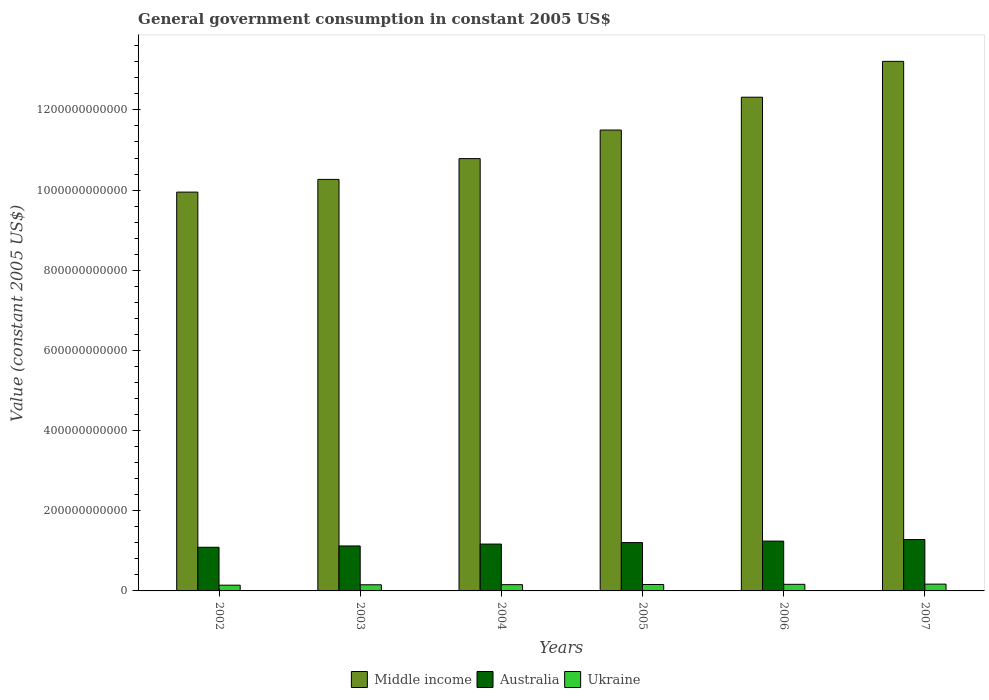How many different coloured bars are there?
Offer a very short reply. 3. How many groups of bars are there?
Offer a very short reply. 6. Are the number of bars on each tick of the X-axis equal?
Your response must be concise. Yes. How many bars are there on the 1st tick from the left?
Ensure brevity in your answer.  3. How many bars are there on the 3rd tick from the right?
Keep it short and to the point. 3. What is the label of the 6th group of bars from the left?
Offer a terse response. 2007. What is the government conusmption in Middle income in 2004?
Offer a very short reply. 1.08e+12. Across all years, what is the maximum government conusmption in Middle income?
Keep it short and to the point. 1.32e+12. Across all years, what is the minimum government conusmption in Ukraine?
Give a very brief answer. 1.43e+1. What is the total government conusmption in Ukraine in the graph?
Your response must be concise. 9.47e+1. What is the difference between the government conusmption in Australia in 2005 and that in 2006?
Provide a succinct answer. -3.73e+09. What is the difference between the government conusmption in Ukraine in 2006 and the government conusmption in Australia in 2004?
Provide a short and direct response. -1.00e+11. What is the average government conusmption in Middle income per year?
Give a very brief answer. 1.13e+12. In the year 2002, what is the difference between the government conusmption in Ukraine and government conusmption in Middle income?
Offer a very short reply. -9.81e+11. What is the ratio of the government conusmption in Ukraine in 2002 to that in 2006?
Give a very brief answer. 0.87. Is the difference between the government conusmption in Ukraine in 2004 and 2005 greater than the difference between the government conusmption in Middle income in 2004 and 2005?
Ensure brevity in your answer.  Yes. What is the difference between the highest and the second highest government conusmption in Australia?
Make the answer very short. 3.94e+09. What is the difference between the highest and the lowest government conusmption in Middle income?
Your response must be concise. 3.26e+11. In how many years, is the government conusmption in Middle income greater than the average government conusmption in Middle income taken over all years?
Make the answer very short. 3. Is the sum of the government conusmption in Australia in 2003 and 2005 greater than the maximum government conusmption in Ukraine across all years?
Provide a short and direct response. Yes. What does the 1st bar from the left in 2004 represents?
Your response must be concise. Middle income. What does the 1st bar from the right in 2003 represents?
Make the answer very short. Ukraine. What is the difference between two consecutive major ticks on the Y-axis?
Offer a terse response. 2.00e+11. Does the graph contain any zero values?
Your answer should be very brief. No. Where does the legend appear in the graph?
Make the answer very short. Bottom center. How are the legend labels stacked?
Offer a terse response. Horizontal. What is the title of the graph?
Make the answer very short. General government consumption in constant 2005 US$. What is the label or title of the X-axis?
Give a very brief answer. Years. What is the label or title of the Y-axis?
Offer a very short reply. Value (constant 2005 US$). What is the Value (constant 2005 US$) of Middle income in 2002?
Your response must be concise. 9.95e+11. What is the Value (constant 2005 US$) of Australia in 2002?
Ensure brevity in your answer.  1.09e+11. What is the Value (constant 2005 US$) in Ukraine in 2002?
Your answer should be very brief. 1.43e+1. What is the Value (constant 2005 US$) of Middle income in 2003?
Keep it short and to the point. 1.03e+12. What is the Value (constant 2005 US$) of Australia in 2003?
Offer a very short reply. 1.12e+11. What is the Value (constant 2005 US$) of Ukraine in 2003?
Your answer should be very brief. 1.53e+1. What is the Value (constant 2005 US$) in Middle income in 2004?
Your answer should be compact. 1.08e+12. What is the Value (constant 2005 US$) in Australia in 2004?
Offer a very short reply. 1.17e+11. What is the Value (constant 2005 US$) in Ukraine in 2004?
Your answer should be very brief. 1.56e+1. What is the Value (constant 2005 US$) in Middle income in 2005?
Your response must be concise. 1.15e+12. What is the Value (constant 2005 US$) of Australia in 2005?
Ensure brevity in your answer.  1.21e+11. What is the Value (constant 2005 US$) in Ukraine in 2005?
Your answer should be compact. 1.61e+1. What is the Value (constant 2005 US$) in Middle income in 2006?
Provide a succinct answer. 1.23e+12. What is the Value (constant 2005 US$) of Australia in 2006?
Give a very brief answer. 1.24e+11. What is the Value (constant 2005 US$) of Ukraine in 2006?
Provide a succinct answer. 1.65e+1. What is the Value (constant 2005 US$) of Middle income in 2007?
Keep it short and to the point. 1.32e+12. What is the Value (constant 2005 US$) in Australia in 2007?
Provide a succinct answer. 1.28e+11. What is the Value (constant 2005 US$) of Ukraine in 2007?
Make the answer very short. 1.69e+1. Across all years, what is the maximum Value (constant 2005 US$) in Middle income?
Provide a succinct answer. 1.32e+12. Across all years, what is the maximum Value (constant 2005 US$) in Australia?
Provide a short and direct response. 1.28e+11. Across all years, what is the maximum Value (constant 2005 US$) in Ukraine?
Your answer should be compact. 1.69e+1. Across all years, what is the minimum Value (constant 2005 US$) of Middle income?
Give a very brief answer. 9.95e+11. Across all years, what is the minimum Value (constant 2005 US$) in Australia?
Give a very brief answer. 1.09e+11. Across all years, what is the minimum Value (constant 2005 US$) in Ukraine?
Provide a succinct answer. 1.43e+1. What is the total Value (constant 2005 US$) in Middle income in the graph?
Keep it short and to the point. 6.80e+12. What is the total Value (constant 2005 US$) of Australia in the graph?
Offer a terse response. 7.11e+11. What is the total Value (constant 2005 US$) of Ukraine in the graph?
Give a very brief answer. 9.47e+1. What is the difference between the Value (constant 2005 US$) in Middle income in 2002 and that in 2003?
Give a very brief answer. -3.17e+1. What is the difference between the Value (constant 2005 US$) in Australia in 2002 and that in 2003?
Ensure brevity in your answer.  -3.25e+09. What is the difference between the Value (constant 2005 US$) in Ukraine in 2002 and that in 2003?
Your response must be concise. -9.89e+08. What is the difference between the Value (constant 2005 US$) of Middle income in 2002 and that in 2004?
Provide a succinct answer. -8.35e+1. What is the difference between the Value (constant 2005 US$) of Australia in 2002 and that in 2004?
Offer a very short reply. -7.94e+09. What is the difference between the Value (constant 2005 US$) in Ukraine in 2002 and that in 2004?
Provide a short and direct response. -1.26e+09. What is the difference between the Value (constant 2005 US$) in Middle income in 2002 and that in 2005?
Provide a short and direct response. -1.55e+11. What is the difference between the Value (constant 2005 US$) in Australia in 2002 and that in 2005?
Provide a succinct answer. -1.16e+1. What is the difference between the Value (constant 2005 US$) of Ukraine in 2002 and that in 2005?
Make the answer very short. -1.72e+09. What is the difference between the Value (constant 2005 US$) in Middle income in 2002 and that in 2006?
Provide a short and direct response. -2.37e+11. What is the difference between the Value (constant 2005 US$) of Australia in 2002 and that in 2006?
Ensure brevity in your answer.  -1.54e+1. What is the difference between the Value (constant 2005 US$) in Ukraine in 2002 and that in 2006?
Your answer should be very brief. -2.15e+09. What is the difference between the Value (constant 2005 US$) of Middle income in 2002 and that in 2007?
Your response must be concise. -3.26e+11. What is the difference between the Value (constant 2005 US$) of Australia in 2002 and that in 2007?
Your answer should be compact. -1.93e+1. What is the difference between the Value (constant 2005 US$) in Ukraine in 2002 and that in 2007?
Provide a short and direct response. -2.61e+09. What is the difference between the Value (constant 2005 US$) of Middle income in 2003 and that in 2004?
Your response must be concise. -5.18e+1. What is the difference between the Value (constant 2005 US$) of Australia in 2003 and that in 2004?
Give a very brief answer. -4.69e+09. What is the difference between the Value (constant 2005 US$) of Ukraine in 2003 and that in 2004?
Ensure brevity in your answer.  -2.76e+08. What is the difference between the Value (constant 2005 US$) of Middle income in 2003 and that in 2005?
Give a very brief answer. -1.23e+11. What is the difference between the Value (constant 2005 US$) of Australia in 2003 and that in 2005?
Offer a terse response. -8.39e+09. What is the difference between the Value (constant 2005 US$) in Ukraine in 2003 and that in 2005?
Your answer should be compact. -7.28e+08. What is the difference between the Value (constant 2005 US$) of Middle income in 2003 and that in 2006?
Make the answer very short. -2.05e+11. What is the difference between the Value (constant 2005 US$) in Australia in 2003 and that in 2006?
Keep it short and to the point. -1.21e+1. What is the difference between the Value (constant 2005 US$) of Ukraine in 2003 and that in 2006?
Your response must be concise. -1.16e+09. What is the difference between the Value (constant 2005 US$) of Middle income in 2003 and that in 2007?
Offer a terse response. -2.95e+11. What is the difference between the Value (constant 2005 US$) in Australia in 2003 and that in 2007?
Your answer should be compact. -1.61e+1. What is the difference between the Value (constant 2005 US$) in Ukraine in 2003 and that in 2007?
Your response must be concise. -1.62e+09. What is the difference between the Value (constant 2005 US$) of Middle income in 2004 and that in 2005?
Your answer should be compact. -7.13e+1. What is the difference between the Value (constant 2005 US$) of Australia in 2004 and that in 2005?
Give a very brief answer. -3.70e+09. What is the difference between the Value (constant 2005 US$) in Ukraine in 2004 and that in 2005?
Your response must be concise. -4.52e+08. What is the difference between the Value (constant 2005 US$) of Middle income in 2004 and that in 2006?
Provide a short and direct response. -1.53e+11. What is the difference between the Value (constant 2005 US$) in Australia in 2004 and that in 2006?
Offer a very short reply. -7.43e+09. What is the difference between the Value (constant 2005 US$) in Ukraine in 2004 and that in 2006?
Your answer should be compact. -8.86e+08. What is the difference between the Value (constant 2005 US$) in Middle income in 2004 and that in 2007?
Your answer should be compact. -2.43e+11. What is the difference between the Value (constant 2005 US$) in Australia in 2004 and that in 2007?
Make the answer very short. -1.14e+1. What is the difference between the Value (constant 2005 US$) in Ukraine in 2004 and that in 2007?
Your answer should be compact. -1.35e+09. What is the difference between the Value (constant 2005 US$) of Middle income in 2005 and that in 2006?
Your answer should be very brief. -8.19e+1. What is the difference between the Value (constant 2005 US$) in Australia in 2005 and that in 2006?
Keep it short and to the point. -3.73e+09. What is the difference between the Value (constant 2005 US$) in Ukraine in 2005 and that in 2006?
Offer a terse response. -4.33e+08. What is the difference between the Value (constant 2005 US$) of Middle income in 2005 and that in 2007?
Your response must be concise. -1.71e+11. What is the difference between the Value (constant 2005 US$) of Australia in 2005 and that in 2007?
Keep it short and to the point. -7.67e+09. What is the difference between the Value (constant 2005 US$) of Ukraine in 2005 and that in 2007?
Provide a succinct answer. -8.95e+08. What is the difference between the Value (constant 2005 US$) of Middle income in 2006 and that in 2007?
Give a very brief answer. -8.94e+1. What is the difference between the Value (constant 2005 US$) of Australia in 2006 and that in 2007?
Give a very brief answer. -3.94e+09. What is the difference between the Value (constant 2005 US$) in Ukraine in 2006 and that in 2007?
Ensure brevity in your answer.  -4.62e+08. What is the difference between the Value (constant 2005 US$) of Middle income in 2002 and the Value (constant 2005 US$) of Australia in 2003?
Keep it short and to the point. 8.83e+11. What is the difference between the Value (constant 2005 US$) of Middle income in 2002 and the Value (constant 2005 US$) of Ukraine in 2003?
Ensure brevity in your answer.  9.80e+11. What is the difference between the Value (constant 2005 US$) in Australia in 2002 and the Value (constant 2005 US$) in Ukraine in 2003?
Ensure brevity in your answer.  9.36e+1. What is the difference between the Value (constant 2005 US$) of Middle income in 2002 and the Value (constant 2005 US$) of Australia in 2004?
Provide a succinct answer. 8.78e+11. What is the difference between the Value (constant 2005 US$) of Middle income in 2002 and the Value (constant 2005 US$) of Ukraine in 2004?
Ensure brevity in your answer.  9.79e+11. What is the difference between the Value (constant 2005 US$) in Australia in 2002 and the Value (constant 2005 US$) in Ukraine in 2004?
Offer a very short reply. 9.33e+1. What is the difference between the Value (constant 2005 US$) in Middle income in 2002 and the Value (constant 2005 US$) in Australia in 2005?
Provide a short and direct response. 8.74e+11. What is the difference between the Value (constant 2005 US$) of Middle income in 2002 and the Value (constant 2005 US$) of Ukraine in 2005?
Offer a very short reply. 9.79e+11. What is the difference between the Value (constant 2005 US$) of Australia in 2002 and the Value (constant 2005 US$) of Ukraine in 2005?
Offer a terse response. 9.29e+1. What is the difference between the Value (constant 2005 US$) of Middle income in 2002 and the Value (constant 2005 US$) of Australia in 2006?
Keep it short and to the point. 8.71e+11. What is the difference between the Value (constant 2005 US$) of Middle income in 2002 and the Value (constant 2005 US$) of Ukraine in 2006?
Provide a succinct answer. 9.78e+11. What is the difference between the Value (constant 2005 US$) in Australia in 2002 and the Value (constant 2005 US$) in Ukraine in 2006?
Ensure brevity in your answer.  9.24e+1. What is the difference between the Value (constant 2005 US$) in Middle income in 2002 and the Value (constant 2005 US$) in Australia in 2007?
Provide a short and direct response. 8.67e+11. What is the difference between the Value (constant 2005 US$) in Middle income in 2002 and the Value (constant 2005 US$) in Ukraine in 2007?
Provide a succinct answer. 9.78e+11. What is the difference between the Value (constant 2005 US$) of Australia in 2002 and the Value (constant 2005 US$) of Ukraine in 2007?
Offer a very short reply. 9.20e+1. What is the difference between the Value (constant 2005 US$) in Middle income in 2003 and the Value (constant 2005 US$) in Australia in 2004?
Keep it short and to the point. 9.10e+11. What is the difference between the Value (constant 2005 US$) of Middle income in 2003 and the Value (constant 2005 US$) of Ukraine in 2004?
Your answer should be compact. 1.01e+12. What is the difference between the Value (constant 2005 US$) of Australia in 2003 and the Value (constant 2005 US$) of Ukraine in 2004?
Give a very brief answer. 9.66e+1. What is the difference between the Value (constant 2005 US$) of Middle income in 2003 and the Value (constant 2005 US$) of Australia in 2005?
Keep it short and to the point. 9.06e+11. What is the difference between the Value (constant 2005 US$) in Middle income in 2003 and the Value (constant 2005 US$) in Ukraine in 2005?
Your answer should be compact. 1.01e+12. What is the difference between the Value (constant 2005 US$) of Australia in 2003 and the Value (constant 2005 US$) of Ukraine in 2005?
Provide a short and direct response. 9.61e+1. What is the difference between the Value (constant 2005 US$) in Middle income in 2003 and the Value (constant 2005 US$) in Australia in 2006?
Keep it short and to the point. 9.02e+11. What is the difference between the Value (constant 2005 US$) in Middle income in 2003 and the Value (constant 2005 US$) in Ukraine in 2006?
Offer a terse response. 1.01e+12. What is the difference between the Value (constant 2005 US$) in Australia in 2003 and the Value (constant 2005 US$) in Ukraine in 2006?
Your answer should be compact. 9.57e+1. What is the difference between the Value (constant 2005 US$) of Middle income in 2003 and the Value (constant 2005 US$) of Australia in 2007?
Provide a succinct answer. 8.98e+11. What is the difference between the Value (constant 2005 US$) of Middle income in 2003 and the Value (constant 2005 US$) of Ukraine in 2007?
Provide a succinct answer. 1.01e+12. What is the difference between the Value (constant 2005 US$) of Australia in 2003 and the Value (constant 2005 US$) of Ukraine in 2007?
Make the answer very short. 9.52e+1. What is the difference between the Value (constant 2005 US$) in Middle income in 2004 and the Value (constant 2005 US$) in Australia in 2005?
Your answer should be very brief. 9.58e+11. What is the difference between the Value (constant 2005 US$) in Middle income in 2004 and the Value (constant 2005 US$) in Ukraine in 2005?
Offer a very short reply. 1.06e+12. What is the difference between the Value (constant 2005 US$) of Australia in 2004 and the Value (constant 2005 US$) of Ukraine in 2005?
Offer a very short reply. 1.01e+11. What is the difference between the Value (constant 2005 US$) in Middle income in 2004 and the Value (constant 2005 US$) in Australia in 2006?
Give a very brief answer. 9.54e+11. What is the difference between the Value (constant 2005 US$) in Middle income in 2004 and the Value (constant 2005 US$) in Ukraine in 2006?
Ensure brevity in your answer.  1.06e+12. What is the difference between the Value (constant 2005 US$) of Australia in 2004 and the Value (constant 2005 US$) of Ukraine in 2006?
Your answer should be very brief. 1.00e+11. What is the difference between the Value (constant 2005 US$) of Middle income in 2004 and the Value (constant 2005 US$) of Australia in 2007?
Offer a terse response. 9.50e+11. What is the difference between the Value (constant 2005 US$) of Middle income in 2004 and the Value (constant 2005 US$) of Ukraine in 2007?
Ensure brevity in your answer.  1.06e+12. What is the difference between the Value (constant 2005 US$) in Australia in 2004 and the Value (constant 2005 US$) in Ukraine in 2007?
Ensure brevity in your answer.  9.99e+1. What is the difference between the Value (constant 2005 US$) in Middle income in 2005 and the Value (constant 2005 US$) in Australia in 2006?
Give a very brief answer. 1.03e+12. What is the difference between the Value (constant 2005 US$) of Middle income in 2005 and the Value (constant 2005 US$) of Ukraine in 2006?
Your answer should be very brief. 1.13e+12. What is the difference between the Value (constant 2005 US$) of Australia in 2005 and the Value (constant 2005 US$) of Ukraine in 2006?
Offer a very short reply. 1.04e+11. What is the difference between the Value (constant 2005 US$) of Middle income in 2005 and the Value (constant 2005 US$) of Australia in 2007?
Provide a succinct answer. 1.02e+12. What is the difference between the Value (constant 2005 US$) of Middle income in 2005 and the Value (constant 2005 US$) of Ukraine in 2007?
Ensure brevity in your answer.  1.13e+12. What is the difference between the Value (constant 2005 US$) in Australia in 2005 and the Value (constant 2005 US$) in Ukraine in 2007?
Offer a very short reply. 1.04e+11. What is the difference between the Value (constant 2005 US$) in Middle income in 2006 and the Value (constant 2005 US$) in Australia in 2007?
Offer a terse response. 1.10e+12. What is the difference between the Value (constant 2005 US$) in Middle income in 2006 and the Value (constant 2005 US$) in Ukraine in 2007?
Keep it short and to the point. 1.21e+12. What is the difference between the Value (constant 2005 US$) of Australia in 2006 and the Value (constant 2005 US$) of Ukraine in 2007?
Ensure brevity in your answer.  1.07e+11. What is the average Value (constant 2005 US$) of Middle income per year?
Provide a succinct answer. 1.13e+12. What is the average Value (constant 2005 US$) of Australia per year?
Keep it short and to the point. 1.19e+11. What is the average Value (constant 2005 US$) in Ukraine per year?
Ensure brevity in your answer.  1.58e+1. In the year 2002, what is the difference between the Value (constant 2005 US$) in Middle income and Value (constant 2005 US$) in Australia?
Ensure brevity in your answer.  8.86e+11. In the year 2002, what is the difference between the Value (constant 2005 US$) in Middle income and Value (constant 2005 US$) in Ukraine?
Provide a succinct answer. 9.81e+11. In the year 2002, what is the difference between the Value (constant 2005 US$) of Australia and Value (constant 2005 US$) of Ukraine?
Your response must be concise. 9.46e+1. In the year 2003, what is the difference between the Value (constant 2005 US$) in Middle income and Value (constant 2005 US$) in Australia?
Give a very brief answer. 9.14e+11. In the year 2003, what is the difference between the Value (constant 2005 US$) of Middle income and Value (constant 2005 US$) of Ukraine?
Your answer should be compact. 1.01e+12. In the year 2003, what is the difference between the Value (constant 2005 US$) in Australia and Value (constant 2005 US$) in Ukraine?
Give a very brief answer. 9.69e+1. In the year 2004, what is the difference between the Value (constant 2005 US$) of Middle income and Value (constant 2005 US$) of Australia?
Your response must be concise. 9.62e+11. In the year 2004, what is the difference between the Value (constant 2005 US$) in Middle income and Value (constant 2005 US$) in Ukraine?
Your answer should be very brief. 1.06e+12. In the year 2004, what is the difference between the Value (constant 2005 US$) of Australia and Value (constant 2005 US$) of Ukraine?
Provide a short and direct response. 1.01e+11. In the year 2005, what is the difference between the Value (constant 2005 US$) in Middle income and Value (constant 2005 US$) in Australia?
Provide a short and direct response. 1.03e+12. In the year 2005, what is the difference between the Value (constant 2005 US$) in Middle income and Value (constant 2005 US$) in Ukraine?
Offer a terse response. 1.13e+12. In the year 2005, what is the difference between the Value (constant 2005 US$) of Australia and Value (constant 2005 US$) of Ukraine?
Your answer should be compact. 1.05e+11. In the year 2006, what is the difference between the Value (constant 2005 US$) in Middle income and Value (constant 2005 US$) in Australia?
Ensure brevity in your answer.  1.11e+12. In the year 2006, what is the difference between the Value (constant 2005 US$) of Middle income and Value (constant 2005 US$) of Ukraine?
Your response must be concise. 1.22e+12. In the year 2006, what is the difference between the Value (constant 2005 US$) in Australia and Value (constant 2005 US$) in Ukraine?
Make the answer very short. 1.08e+11. In the year 2007, what is the difference between the Value (constant 2005 US$) in Middle income and Value (constant 2005 US$) in Australia?
Keep it short and to the point. 1.19e+12. In the year 2007, what is the difference between the Value (constant 2005 US$) of Middle income and Value (constant 2005 US$) of Ukraine?
Ensure brevity in your answer.  1.30e+12. In the year 2007, what is the difference between the Value (constant 2005 US$) of Australia and Value (constant 2005 US$) of Ukraine?
Provide a short and direct response. 1.11e+11. What is the ratio of the Value (constant 2005 US$) in Middle income in 2002 to that in 2003?
Ensure brevity in your answer.  0.97. What is the ratio of the Value (constant 2005 US$) in Ukraine in 2002 to that in 2003?
Provide a short and direct response. 0.94. What is the ratio of the Value (constant 2005 US$) of Middle income in 2002 to that in 2004?
Provide a short and direct response. 0.92. What is the ratio of the Value (constant 2005 US$) of Australia in 2002 to that in 2004?
Provide a short and direct response. 0.93. What is the ratio of the Value (constant 2005 US$) in Ukraine in 2002 to that in 2004?
Provide a short and direct response. 0.92. What is the ratio of the Value (constant 2005 US$) in Middle income in 2002 to that in 2005?
Your response must be concise. 0.87. What is the ratio of the Value (constant 2005 US$) of Australia in 2002 to that in 2005?
Ensure brevity in your answer.  0.9. What is the ratio of the Value (constant 2005 US$) of Ukraine in 2002 to that in 2005?
Make the answer very short. 0.89. What is the ratio of the Value (constant 2005 US$) in Middle income in 2002 to that in 2006?
Provide a short and direct response. 0.81. What is the ratio of the Value (constant 2005 US$) in Australia in 2002 to that in 2006?
Offer a terse response. 0.88. What is the ratio of the Value (constant 2005 US$) of Ukraine in 2002 to that in 2006?
Give a very brief answer. 0.87. What is the ratio of the Value (constant 2005 US$) in Middle income in 2002 to that in 2007?
Your answer should be very brief. 0.75. What is the ratio of the Value (constant 2005 US$) of Australia in 2002 to that in 2007?
Your answer should be very brief. 0.85. What is the ratio of the Value (constant 2005 US$) in Ukraine in 2002 to that in 2007?
Keep it short and to the point. 0.85. What is the ratio of the Value (constant 2005 US$) of Middle income in 2003 to that in 2004?
Provide a succinct answer. 0.95. What is the ratio of the Value (constant 2005 US$) in Australia in 2003 to that in 2004?
Make the answer very short. 0.96. What is the ratio of the Value (constant 2005 US$) in Ukraine in 2003 to that in 2004?
Your answer should be very brief. 0.98. What is the ratio of the Value (constant 2005 US$) in Middle income in 2003 to that in 2005?
Give a very brief answer. 0.89. What is the ratio of the Value (constant 2005 US$) in Australia in 2003 to that in 2005?
Give a very brief answer. 0.93. What is the ratio of the Value (constant 2005 US$) of Ukraine in 2003 to that in 2005?
Your answer should be very brief. 0.95. What is the ratio of the Value (constant 2005 US$) of Middle income in 2003 to that in 2006?
Offer a terse response. 0.83. What is the ratio of the Value (constant 2005 US$) of Australia in 2003 to that in 2006?
Your answer should be very brief. 0.9. What is the ratio of the Value (constant 2005 US$) of Ukraine in 2003 to that in 2006?
Your answer should be compact. 0.93. What is the ratio of the Value (constant 2005 US$) of Middle income in 2003 to that in 2007?
Give a very brief answer. 0.78. What is the ratio of the Value (constant 2005 US$) of Australia in 2003 to that in 2007?
Offer a very short reply. 0.87. What is the ratio of the Value (constant 2005 US$) in Ukraine in 2003 to that in 2007?
Keep it short and to the point. 0.9. What is the ratio of the Value (constant 2005 US$) in Middle income in 2004 to that in 2005?
Make the answer very short. 0.94. What is the ratio of the Value (constant 2005 US$) of Australia in 2004 to that in 2005?
Your answer should be very brief. 0.97. What is the ratio of the Value (constant 2005 US$) in Ukraine in 2004 to that in 2005?
Your answer should be compact. 0.97. What is the ratio of the Value (constant 2005 US$) in Middle income in 2004 to that in 2006?
Ensure brevity in your answer.  0.88. What is the ratio of the Value (constant 2005 US$) in Australia in 2004 to that in 2006?
Give a very brief answer. 0.94. What is the ratio of the Value (constant 2005 US$) of Ukraine in 2004 to that in 2006?
Make the answer very short. 0.95. What is the ratio of the Value (constant 2005 US$) of Middle income in 2004 to that in 2007?
Provide a short and direct response. 0.82. What is the ratio of the Value (constant 2005 US$) of Australia in 2004 to that in 2007?
Make the answer very short. 0.91. What is the ratio of the Value (constant 2005 US$) in Ukraine in 2004 to that in 2007?
Provide a short and direct response. 0.92. What is the ratio of the Value (constant 2005 US$) in Middle income in 2005 to that in 2006?
Your answer should be very brief. 0.93. What is the ratio of the Value (constant 2005 US$) in Australia in 2005 to that in 2006?
Make the answer very short. 0.97. What is the ratio of the Value (constant 2005 US$) of Ukraine in 2005 to that in 2006?
Offer a very short reply. 0.97. What is the ratio of the Value (constant 2005 US$) in Middle income in 2005 to that in 2007?
Your response must be concise. 0.87. What is the ratio of the Value (constant 2005 US$) of Australia in 2005 to that in 2007?
Provide a short and direct response. 0.94. What is the ratio of the Value (constant 2005 US$) in Ukraine in 2005 to that in 2007?
Your answer should be compact. 0.95. What is the ratio of the Value (constant 2005 US$) of Middle income in 2006 to that in 2007?
Your answer should be compact. 0.93. What is the ratio of the Value (constant 2005 US$) in Australia in 2006 to that in 2007?
Your answer should be very brief. 0.97. What is the ratio of the Value (constant 2005 US$) in Ukraine in 2006 to that in 2007?
Your answer should be very brief. 0.97. What is the difference between the highest and the second highest Value (constant 2005 US$) in Middle income?
Offer a very short reply. 8.94e+1. What is the difference between the highest and the second highest Value (constant 2005 US$) in Australia?
Your response must be concise. 3.94e+09. What is the difference between the highest and the second highest Value (constant 2005 US$) in Ukraine?
Make the answer very short. 4.62e+08. What is the difference between the highest and the lowest Value (constant 2005 US$) of Middle income?
Your answer should be compact. 3.26e+11. What is the difference between the highest and the lowest Value (constant 2005 US$) of Australia?
Your answer should be compact. 1.93e+1. What is the difference between the highest and the lowest Value (constant 2005 US$) of Ukraine?
Offer a very short reply. 2.61e+09. 